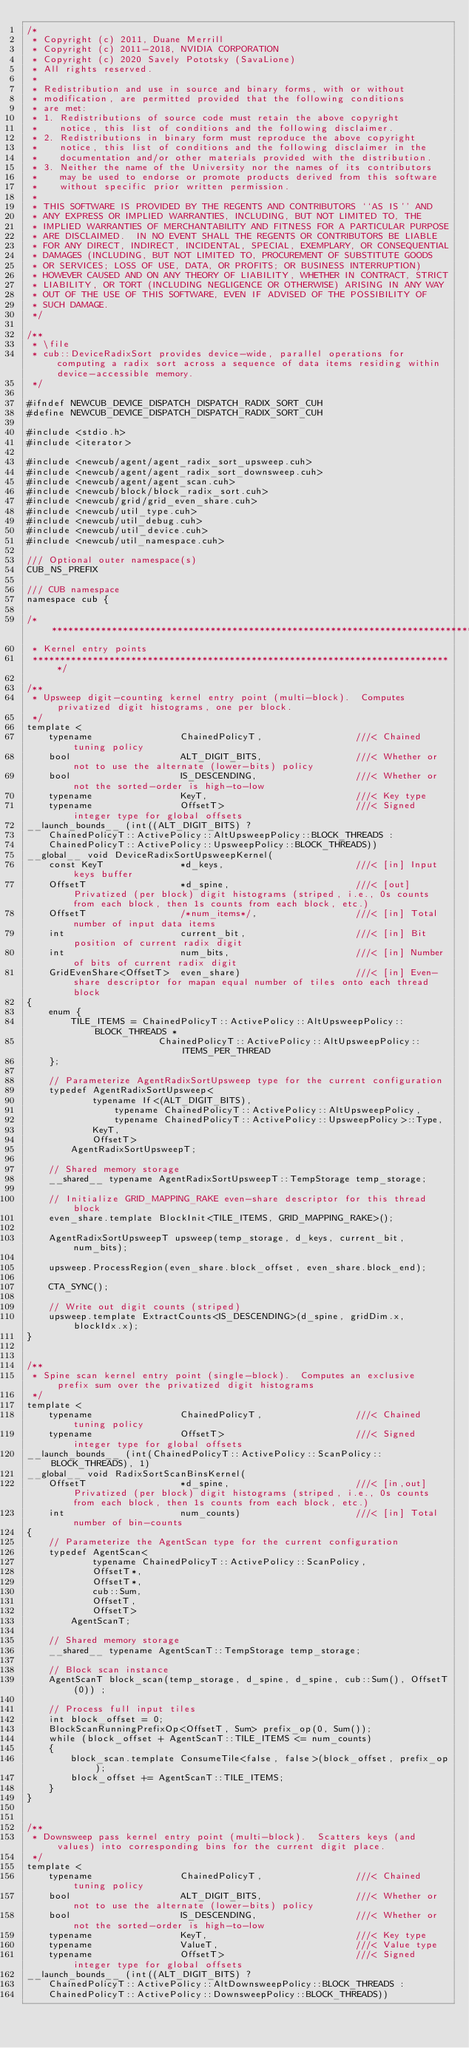Convert code to text. <code><loc_0><loc_0><loc_500><loc_500><_Cuda_>/*
 * Copyright (c) 2011, Duane Merrill
 * Copyright (c) 2011-2018, NVIDIA CORPORATION
 * Copyright (c) 2020 Savely Pototsky (SavaLione)
 * All rights reserved.
 *
 * Redistribution and use in source and binary forms, with or without
 * modification, are permitted provided that the following conditions
 * are met:
 * 1. Redistributions of source code must retain the above copyright
 *    notice, this list of conditions and the following disclaimer.
 * 2. Redistributions in binary form must reproduce the above copyright
 *    notice, this list of conditions and the following disclaimer in the
 *    documentation and/or other materials provided with the distribution.
 * 3. Neither the name of the University nor the names of its contributors
 *    may be used to endorse or promote products derived from this software
 *    without specific prior written permission.
 *
 * THIS SOFTWARE IS PROVIDED BY THE REGENTS AND CONTRIBUTORS ``AS IS'' AND
 * ANY EXPRESS OR IMPLIED WARRANTIES, INCLUDING, BUT NOT LIMITED TO, THE
 * IMPLIED WARRANTIES OF MERCHANTABILITY AND FITNESS FOR A PARTICULAR PURPOSE
 * ARE DISCLAIMED.  IN NO EVENT SHALL THE REGENTS OR CONTRIBUTORS BE LIABLE
 * FOR ANY DIRECT, INDIRECT, INCIDENTAL, SPECIAL, EXEMPLARY, OR CONSEQUENTIAL
 * DAMAGES (INCLUDING, BUT NOT LIMITED TO, PROCUREMENT OF SUBSTITUTE GOODS
 * OR SERVICES; LOSS OF USE, DATA, OR PROFITS; OR BUSINESS INTERRUPTION)
 * HOWEVER CAUSED AND ON ANY THEORY OF LIABILITY, WHETHER IN CONTRACT, STRICT
 * LIABILITY, OR TORT (INCLUDING NEGLIGENCE OR OTHERWISE) ARISING IN ANY WAY
 * OUT OF THE USE OF THIS SOFTWARE, EVEN IF ADVISED OF THE POSSIBILITY OF
 * SUCH DAMAGE.
 */

/**
 * \file
 * cub::DeviceRadixSort provides device-wide, parallel operations for computing a radix sort across a sequence of data items residing within device-accessible memory.
 */

#ifndef NEWCUB_DEVICE_DISPATCH_DISPATCH_RADIX_SORT_CUH
#define NEWCUB_DEVICE_DISPATCH_DISPATCH_RADIX_SORT_CUH

#include <stdio.h>
#include <iterator>

#include <newcub/agent/agent_radix_sort_upsweep.cuh>
#include <newcub/agent/agent_radix_sort_downsweep.cuh>
#include <newcub/agent/agent_scan.cuh>
#include <newcub/block/block_radix_sort.cuh>
#include <newcub/grid/grid_even_share.cuh>
#include <newcub/util_type.cuh>
#include <newcub/util_debug.cuh>
#include <newcub/util_device.cuh>
#include <newcub/util_namespace.cuh>

/// Optional outer namespace(s)
CUB_NS_PREFIX

/// CUB namespace
namespace cub {

/******************************************************************************
 * Kernel entry points
 *****************************************************************************/

/**
 * Upsweep digit-counting kernel entry point (multi-block).  Computes privatized digit histograms, one per block.
 */
template <
    typename                ChainedPolicyT,                 ///< Chained tuning policy
    bool                    ALT_DIGIT_BITS,                 ///< Whether or not to use the alternate (lower-bits) policy
    bool                    IS_DESCENDING,                  ///< Whether or not the sorted-order is high-to-low
    typename                KeyT,                           ///< Key type
    typename                OffsetT>                        ///< Signed integer type for global offsets
__launch_bounds__ (int((ALT_DIGIT_BITS) ?
    ChainedPolicyT::ActivePolicy::AltUpsweepPolicy::BLOCK_THREADS :
    ChainedPolicyT::ActivePolicy::UpsweepPolicy::BLOCK_THREADS))
__global__ void DeviceRadixSortUpsweepKernel(
    const KeyT              *d_keys,                        ///< [in] Input keys buffer
    OffsetT                 *d_spine,                       ///< [out] Privatized (per block) digit histograms (striped, i.e., 0s counts from each block, then 1s counts from each block, etc.)
    OffsetT                 /*num_items*/,                  ///< [in] Total number of input data items
    int                     current_bit,                    ///< [in] Bit position of current radix digit
    int                     num_bits,                       ///< [in] Number of bits of current radix digit
    GridEvenShare<OffsetT>  even_share)                     ///< [in] Even-share descriptor for mapan equal number of tiles onto each thread block
{
    enum {
        TILE_ITEMS = ChainedPolicyT::ActivePolicy::AltUpsweepPolicy::BLOCK_THREADS *
                        ChainedPolicyT::ActivePolicy::AltUpsweepPolicy::ITEMS_PER_THREAD
    };

    // Parameterize AgentRadixSortUpsweep type for the current configuration
    typedef AgentRadixSortUpsweep<
            typename If<(ALT_DIGIT_BITS),
                typename ChainedPolicyT::ActivePolicy::AltUpsweepPolicy,
                typename ChainedPolicyT::ActivePolicy::UpsweepPolicy>::Type,
            KeyT,
            OffsetT>
        AgentRadixSortUpsweepT;

    // Shared memory storage
    __shared__ typename AgentRadixSortUpsweepT::TempStorage temp_storage;

    // Initialize GRID_MAPPING_RAKE even-share descriptor for this thread block
    even_share.template BlockInit<TILE_ITEMS, GRID_MAPPING_RAKE>();

    AgentRadixSortUpsweepT upsweep(temp_storage, d_keys, current_bit, num_bits);

    upsweep.ProcessRegion(even_share.block_offset, even_share.block_end);

    CTA_SYNC();

    // Write out digit counts (striped)
    upsweep.template ExtractCounts<IS_DESCENDING>(d_spine, gridDim.x, blockIdx.x);
}


/**
 * Spine scan kernel entry point (single-block).  Computes an exclusive prefix sum over the privatized digit histograms
 */
template <
    typename                ChainedPolicyT,                 ///< Chained tuning policy
    typename                OffsetT>                        ///< Signed integer type for global offsets
__launch_bounds__ (int(ChainedPolicyT::ActivePolicy::ScanPolicy::BLOCK_THREADS), 1)
__global__ void RadixSortScanBinsKernel(
    OffsetT                 *d_spine,                       ///< [in,out] Privatized (per block) digit histograms (striped, i.e., 0s counts from each block, then 1s counts from each block, etc.)
    int                     num_counts)                     ///< [in] Total number of bin-counts
{
    // Parameterize the AgentScan type for the current configuration
    typedef AgentScan<
            typename ChainedPolicyT::ActivePolicy::ScanPolicy,
            OffsetT*,
            OffsetT*,
            cub::Sum,
            OffsetT,
            OffsetT>
        AgentScanT;

    // Shared memory storage
    __shared__ typename AgentScanT::TempStorage temp_storage;

    // Block scan instance
    AgentScanT block_scan(temp_storage, d_spine, d_spine, cub::Sum(), OffsetT(0)) ;

    // Process full input tiles
    int block_offset = 0;
    BlockScanRunningPrefixOp<OffsetT, Sum> prefix_op(0, Sum());
    while (block_offset + AgentScanT::TILE_ITEMS <= num_counts)
    {
        block_scan.template ConsumeTile<false, false>(block_offset, prefix_op);
        block_offset += AgentScanT::TILE_ITEMS;
    }
}


/**
 * Downsweep pass kernel entry point (multi-block).  Scatters keys (and values) into corresponding bins for the current digit place.
 */
template <
    typename                ChainedPolicyT,                 ///< Chained tuning policy
    bool                    ALT_DIGIT_BITS,                 ///< Whether or not to use the alternate (lower-bits) policy
    bool                    IS_DESCENDING,                  ///< Whether or not the sorted-order is high-to-low
    typename                KeyT,                           ///< Key type
    typename                ValueT,                         ///< Value type
    typename                OffsetT>                        ///< Signed integer type for global offsets
__launch_bounds__ (int((ALT_DIGIT_BITS) ?
    ChainedPolicyT::ActivePolicy::AltDownsweepPolicy::BLOCK_THREADS :
    ChainedPolicyT::ActivePolicy::DownsweepPolicy::BLOCK_THREADS))</code> 